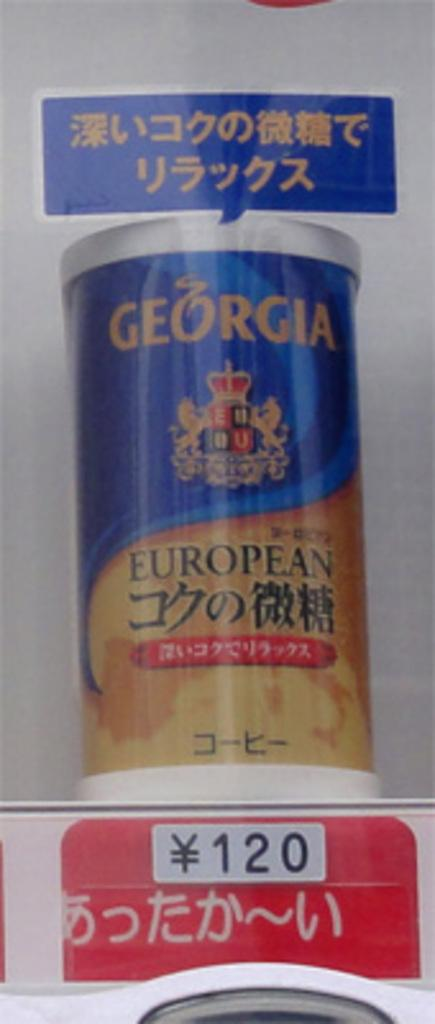<image>
Relay a brief, clear account of the picture shown. Georgia European is for sale in an asian store. 